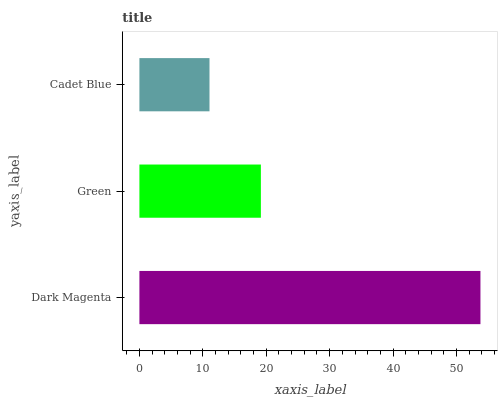Is Cadet Blue the minimum?
Answer yes or no. Yes. Is Dark Magenta the maximum?
Answer yes or no. Yes. Is Green the minimum?
Answer yes or no. No. Is Green the maximum?
Answer yes or no. No. Is Dark Magenta greater than Green?
Answer yes or no. Yes. Is Green less than Dark Magenta?
Answer yes or no. Yes. Is Green greater than Dark Magenta?
Answer yes or no. No. Is Dark Magenta less than Green?
Answer yes or no. No. Is Green the high median?
Answer yes or no. Yes. Is Green the low median?
Answer yes or no. Yes. Is Dark Magenta the high median?
Answer yes or no. No. Is Dark Magenta the low median?
Answer yes or no. No. 